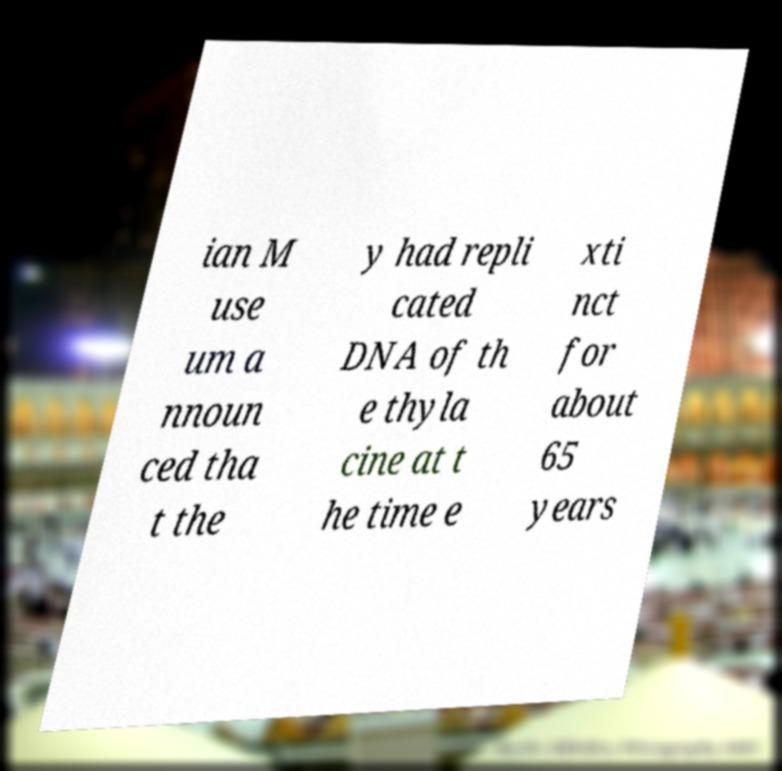Can you accurately transcribe the text from the provided image for me? ian M use um a nnoun ced tha t the y had repli cated DNA of th e thyla cine at t he time e xti nct for about 65 years 